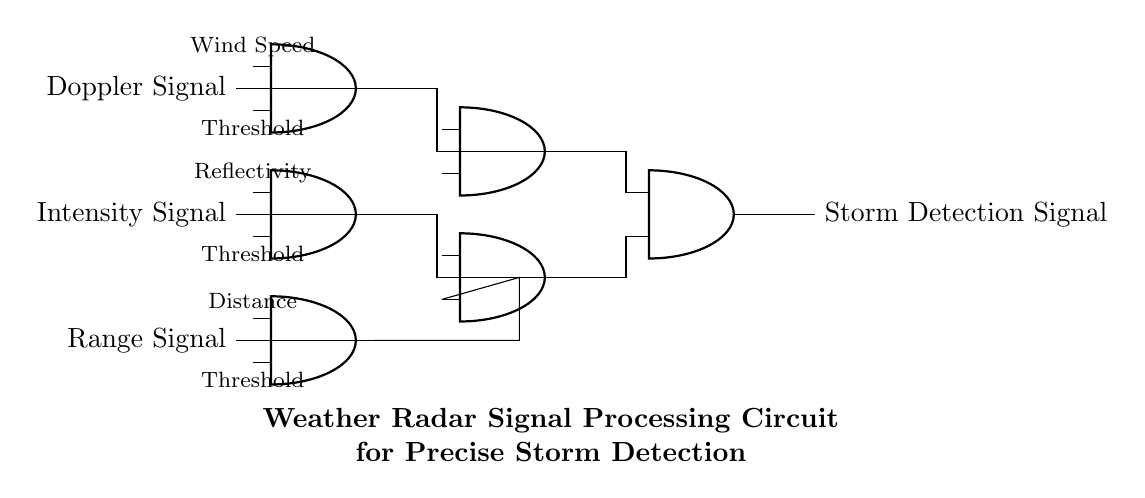What are the input signals to the AND gates? The input signals to the AND gates are Doppler Signal, Intensity Signal, and Range Signal, as indicated on the left side of the diagram.
Answer: Doppler Signal, Intensity Signal, Range Signal How many AND gates are present in the circuit? The circuit features six AND gates as identified throughout the diagram, each performing various logical operations on the input signals.
Answer: Six What type of output does this circuit produce? The output of this circuit is a Storm Detection Signal, which is the final output from the last AND gate in the circuit.
Answer: Storm Detection Signal What threshold parameters are used for the AND gates? Each AND gate has associated threshold parameters: Wind Speed, Reflectivity, and Distance, as shown below their respective inputs in the diagram.
Answer: Wind Speed, Reflectivity, Distance Which signals combine to produce the final Storm Detection Signal? The signals that combine to produce the final Storm Detection Signal are outputs from AND gates formed by the Doppler Signal and Intensity Signal, and the Range Signal with their respective thresholds.
Answer: Outputs from the previous AND gates 